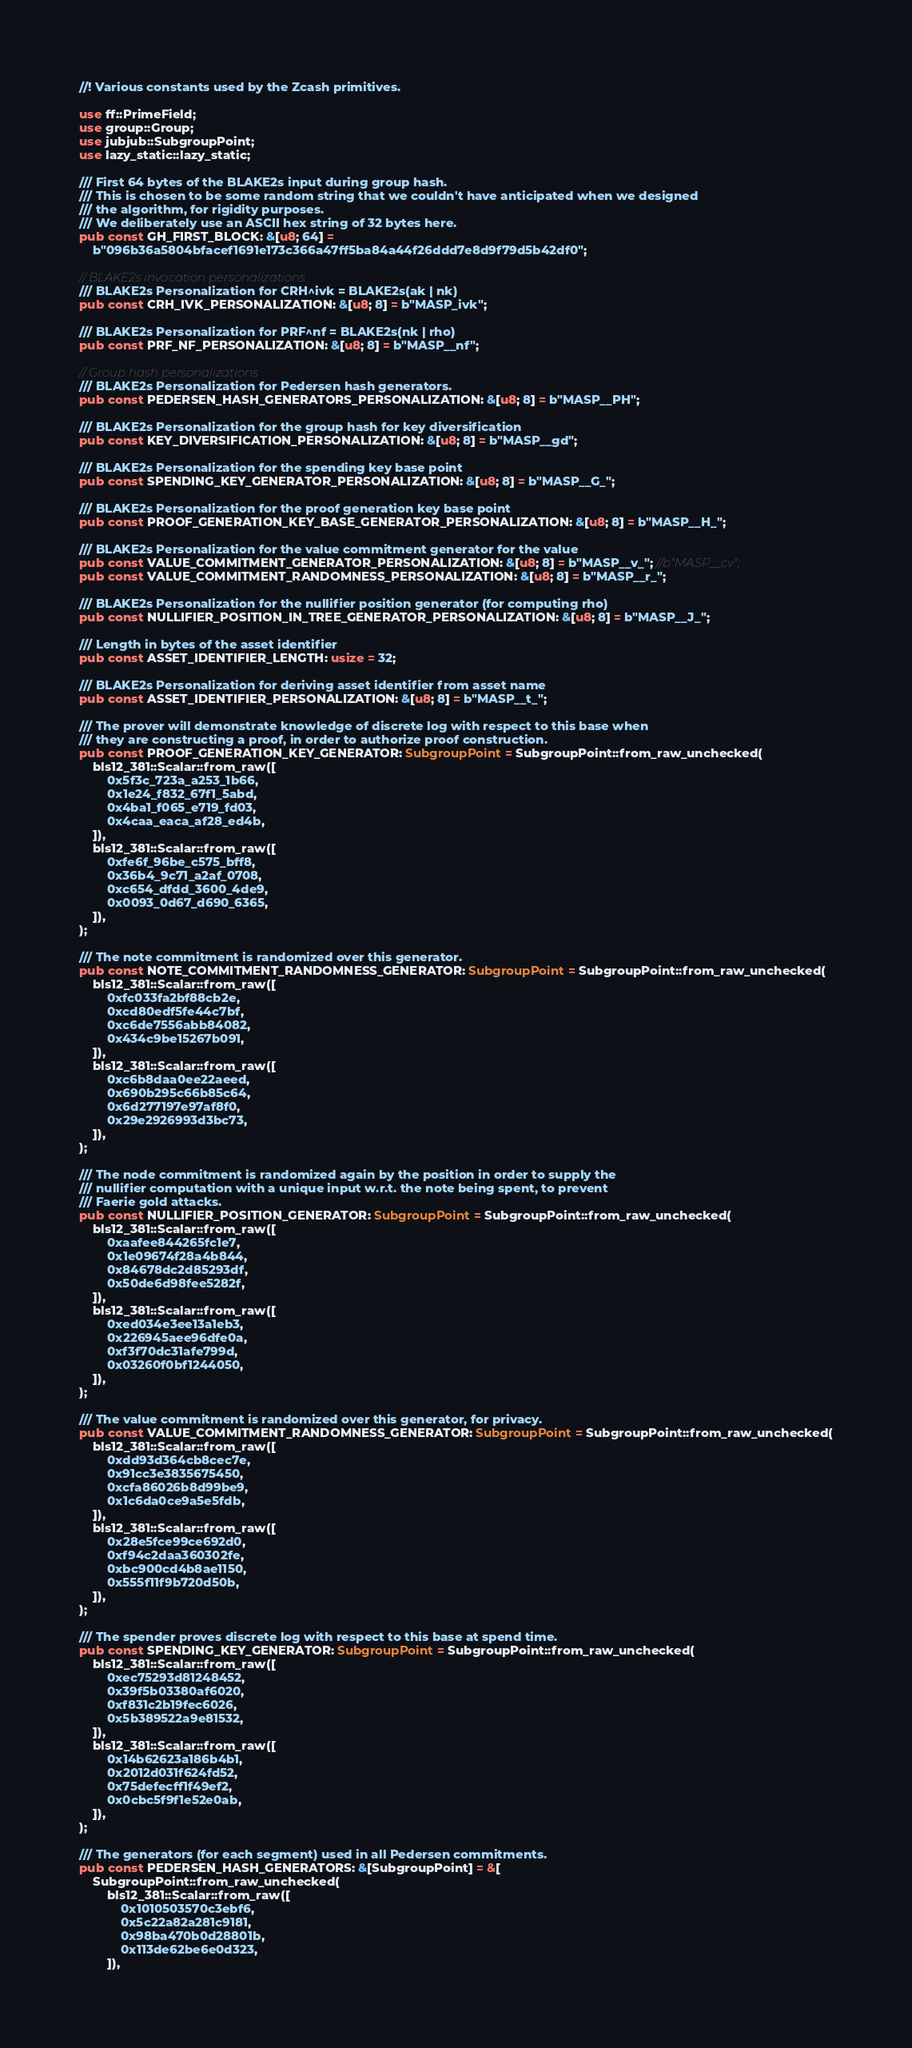<code> <loc_0><loc_0><loc_500><loc_500><_Rust_>//! Various constants used by the Zcash primitives.

use ff::PrimeField;
use group::Group;
use jubjub::SubgroupPoint;
use lazy_static::lazy_static;

/// First 64 bytes of the BLAKE2s input during group hash.
/// This is chosen to be some random string that we couldn't have anticipated when we designed
/// the algorithm, for rigidity purposes.
/// We deliberately use an ASCII hex string of 32 bytes here.
pub const GH_FIRST_BLOCK: &[u8; 64] =
    b"096b36a5804bfacef1691e173c366a47ff5ba84a44f26ddd7e8d9f79d5b42df0";

// BLAKE2s invocation personalizations
/// BLAKE2s Personalization for CRH^ivk = BLAKE2s(ak | nk)
pub const CRH_IVK_PERSONALIZATION: &[u8; 8] = b"MASP_ivk";

/// BLAKE2s Personalization for PRF^nf = BLAKE2s(nk | rho)
pub const PRF_NF_PERSONALIZATION: &[u8; 8] = b"MASP__nf";

// Group hash personalizations
/// BLAKE2s Personalization for Pedersen hash generators.
pub const PEDERSEN_HASH_GENERATORS_PERSONALIZATION: &[u8; 8] = b"MASP__PH";

/// BLAKE2s Personalization for the group hash for key diversification
pub const KEY_DIVERSIFICATION_PERSONALIZATION: &[u8; 8] = b"MASP__gd";

/// BLAKE2s Personalization for the spending key base point
pub const SPENDING_KEY_GENERATOR_PERSONALIZATION: &[u8; 8] = b"MASP__G_";

/// BLAKE2s Personalization for the proof generation key base point
pub const PROOF_GENERATION_KEY_BASE_GENERATOR_PERSONALIZATION: &[u8; 8] = b"MASP__H_";

/// BLAKE2s Personalization for the value commitment generator for the value
pub const VALUE_COMMITMENT_GENERATOR_PERSONALIZATION: &[u8; 8] = b"MASP__v_"; //b"MASP__cv";
pub const VALUE_COMMITMENT_RANDOMNESS_PERSONALIZATION: &[u8; 8] = b"MASP__r_";

/// BLAKE2s Personalization for the nullifier position generator (for computing rho)
pub const NULLIFIER_POSITION_IN_TREE_GENERATOR_PERSONALIZATION: &[u8; 8] = b"MASP__J_";

/// Length in bytes of the asset identifier
pub const ASSET_IDENTIFIER_LENGTH: usize = 32;

/// BLAKE2s Personalization for deriving asset identifier from asset name
pub const ASSET_IDENTIFIER_PERSONALIZATION: &[u8; 8] = b"MASP__t_";

/// The prover will demonstrate knowledge of discrete log with respect to this base when
/// they are constructing a proof, in order to authorize proof construction.
pub const PROOF_GENERATION_KEY_GENERATOR: SubgroupPoint = SubgroupPoint::from_raw_unchecked(
    bls12_381::Scalar::from_raw([
        0x5f3c_723a_a253_1b66,
        0x1e24_f832_67f1_5abd,
        0x4ba1_f065_e719_fd03,
        0x4caa_eaca_af28_ed4b,
    ]),
    bls12_381::Scalar::from_raw([
        0xfe6f_96be_c575_bff8,
        0x36b4_9c71_a2af_0708,
        0xc654_dfdd_3600_4de9,
        0x0093_0d67_d690_6365,
    ]),
);

/// The note commitment is randomized over this generator.
pub const NOTE_COMMITMENT_RANDOMNESS_GENERATOR: SubgroupPoint = SubgroupPoint::from_raw_unchecked(
    bls12_381::Scalar::from_raw([
        0xfc033fa2bf88cb2e,
        0xcd80edf5fe44c7bf,
        0xc6de7556abb84082,
        0x434c9be15267b091,
    ]),
    bls12_381::Scalar::from_raw([
        0xc6b8daa0ee22aeed,
        0x690b295c66b85c64,
        0x6d277197e97af8f0,
        0x29e2926993d3bc73,
    ]),
);

/// The node commitment is randomized again by the position in order to supply the
/// nullifier computation with a unique input w.r.t. the note being spent, to prevent
/// Faerie gold attacks.
pub const NULLIFIER_POSITION_GENERATOR: SubgroupPoint = SubgroupPoint::from_raw_unchecked(
    bls12_381::Scalar::from_raw([
        0xaafee844265fc1e7,
        0x1e09674f28a4b844,
        0x84678dc2d85293df,
        0x50de6d98fee5282f,
    ]),
    bls12_381::Scalar::from_raw([
        0xed034e3ee13a1eb3,
        0x226945aee96dfe0a,
        0xf3f70dc31afe799d,
        0x03260f0bf1244050,
    ]),
);

/// The value commitment is randomized over this generator, for privacy.
pub const VALUE_COMMITMENT_RANDOMNESS_GENERATOR: SubgroupPoint = SubgroupPoint::from_raw_unchecked(
    bls12_381::Scalar::from_raw([
        0xdd93d364cb8cec7e,
        0x91cc3e3835675450,
        0xcfa86026b8d99be9,
        0x1c6da0ce9a5e5fdb,
    ]),
    bls12_381::Scalar::from_raw([
        0x28e5fce99ce692d0,
        0xf94c2daa360302fe,
        0xbc900cd4b8ae1150,
        0x555f11f9b720d50b,
    ]),
);

/// The spender proves discrete log with respect to this base at spend time.
pub const SPENDING_KEY_GENERATOR: SubgroupPoint = SubgroupPoint::from_raw_unchecked(
    bls12_381::Scalar::from_raw([
        0xec75293d81248452,
        0x39f5b03380af6020,
        0xf831c2b19fec6026,
        0x5b389522a9e81532,
    ]),
    bls12_381::Scalar::from_raw([
        0x14b62623a186b4b1,
        0x2012d031f624fd52,
        0x75defecff1f49ef2,
        0x0cbc5f9f1e52e0ab,
    ]),
);

/// The generators (for each segment) used in all Pedersen commitments.
pub const PEDERSEN_HASH_GENERATORS: &[SubgroupPoint] = &[
    SubgroupPoint::from_raw_unchecked(
        bls12_381::Scalar::from_raw([
            0x1010503570c3ebf6,
            0x5c22a82a281c9181,
            0x98ba470b0d28801b,
            0x113de62be6e0d323,
        ]),</code> 